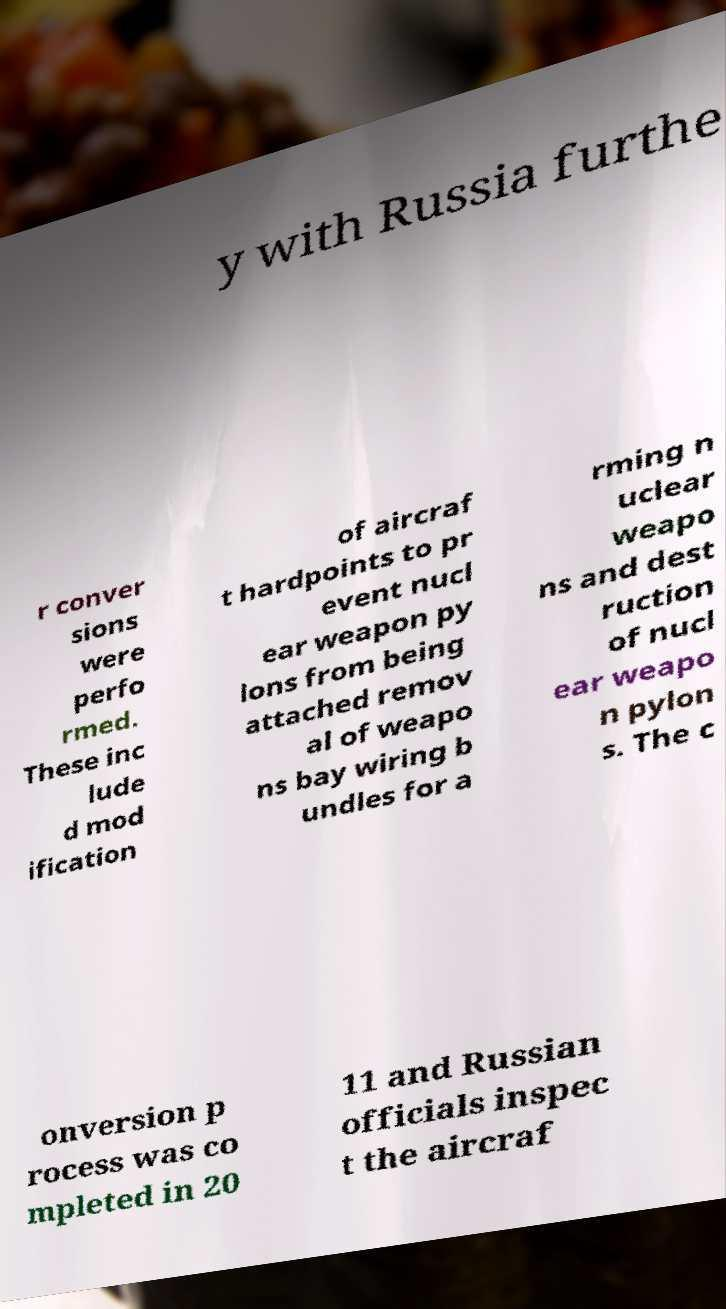For documentation purposes, I need the text within this image transcribed. Could you provide that? y with Russia furthe r conver sions were perfo rmed. These inc lude d mod ification of aircraf t hardpoints to pr event nucl ear weapon py lons from being attached remov al of weapo ns bay wiring b undles for a rming n uclear weapo ns and dest ruction of nucl ear weapo n pylon s. The c onversion p rocess was co mpleted in 20 11 and Russian officials inspec t the aircraf 